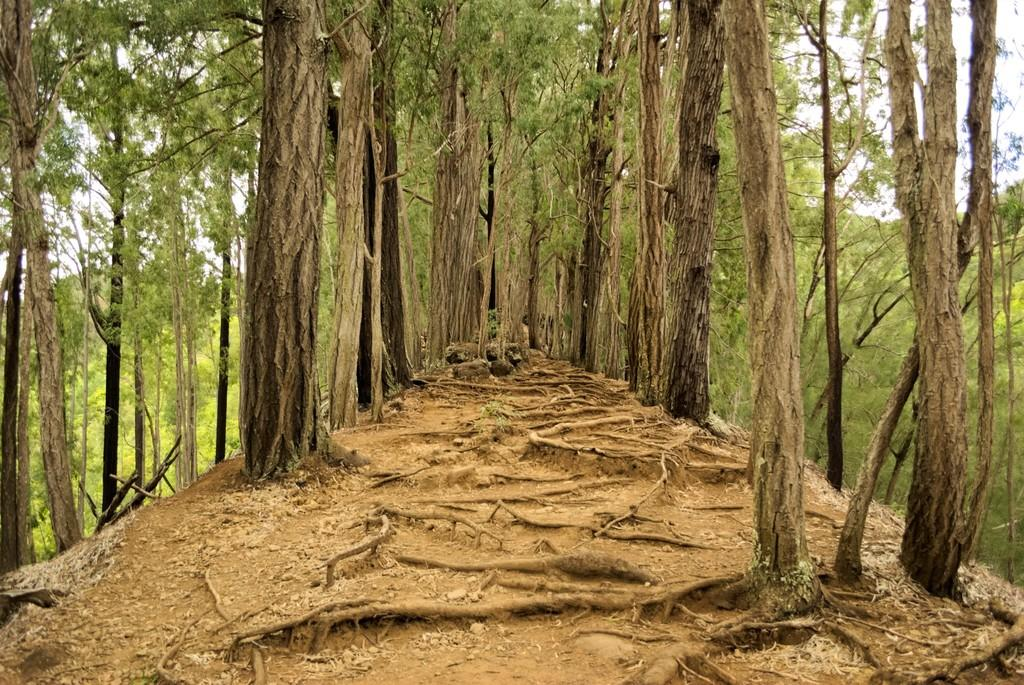What type of vegetation can be seen in the image? There are trees in the image. What part of the trees is visible in the image? There are roots visible in the image. What is visible in the background of the image? The sky is visible in the background of the image. How many cherries are hanging from the tree in the image? There are no cherries visible in the image; only trees and roots are present. Can you see the elbow of the person who planted the tree in the image? There is no person present in the image, so it is not possible to see their elbow. 